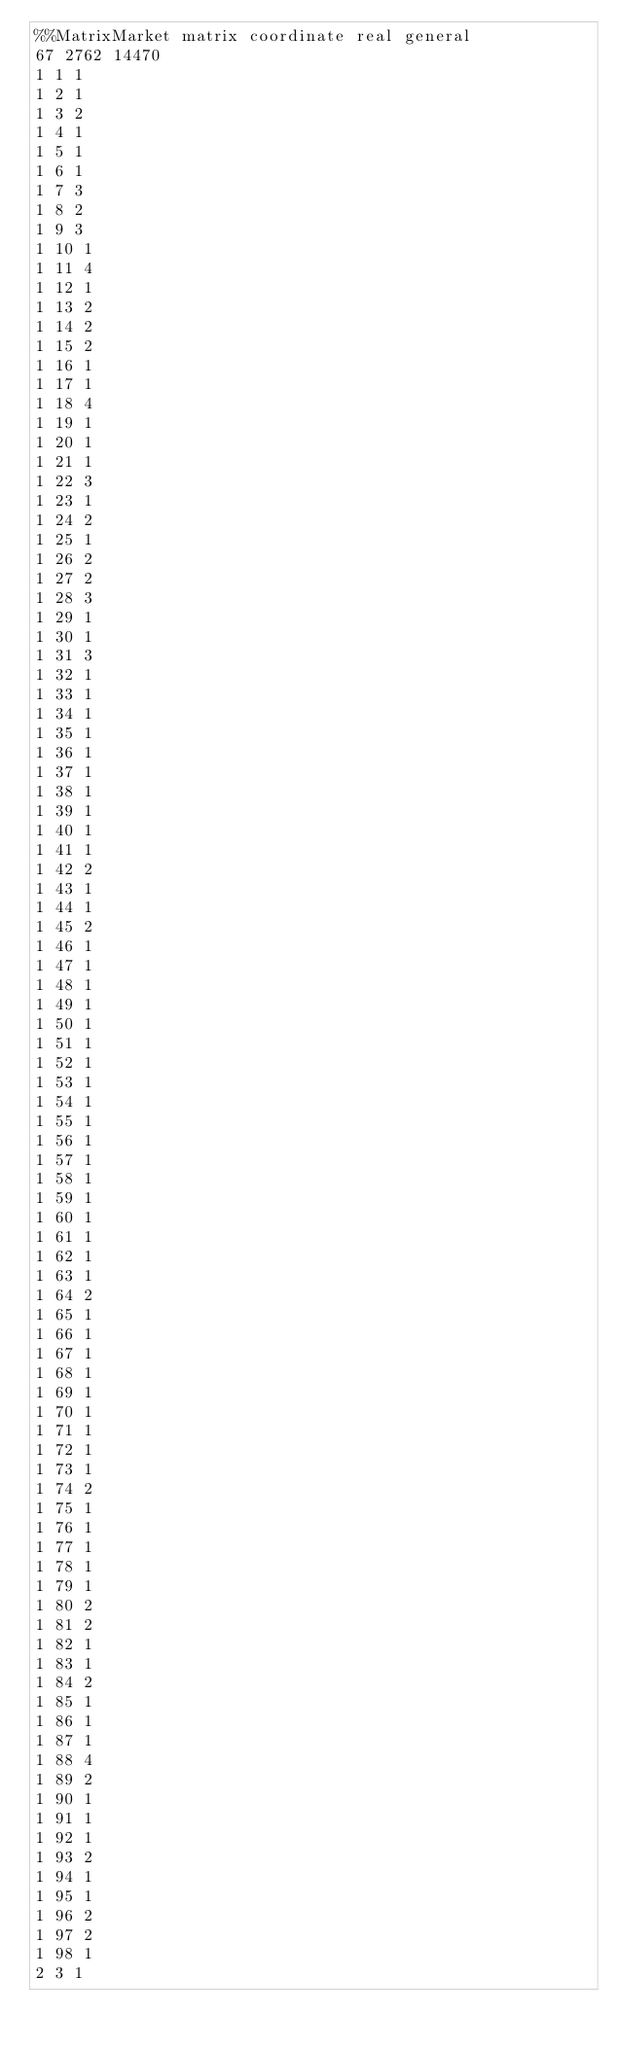Convert code to text. <code><loc_0><loc_0><loc_500><loc_500><_ObjectiveC_>%%MatrixMarket matrix coordinate real general
67 2762 14470                                     
1 1 1
1 2 1
1 3 2
1 4 1
1 5 1
1 6 1
1 7 3
1 8 2
1 9 3
1 10 1
1 11 4
1 12 1
1 13 2
1 14 2
1 15 2
1 16 1
1 17 1
1 18 4
1 19 1
1 20 1
1 21 1
1 22 3
1 23 1
1 24 2
1 25 1
1 26 2
1 27 2
1 28 3
1 29 1
1 30 1
1 31 3
1 32 1
1 33 1
1 34 1
1 35 1
1 36 1
1 37 1
1 38 1
1 39 1
1 40 1
1 41 1
1 42 2
1 43 1
1 44 1
1 45 2
1 46 1
1 47 1
1 48 1
1 49 1
1 50 1
1 51 1
1 52 1
1 53 1
1 54 1
1 55 1
1 56 1
1 57 1
1 58 1
1 59 1
1 60 1
1 61 1
1 62 1
1 63 1
1 64 2
1 65 1
1 66 1
1 67 1
1 68 1
1 69 1
1 70 1
1 71 1
1 72 1
1 73 1
1 74 2
1 75 1
1 76 1
1 77 1
1 78 1
1 79 1
1 80 2
1 81 2
1 82 1
1 83 1
1 84 2
1 85 1
1 86 1
1 87 1
1 88 4
1 89 2
1 90 1
1 91 1
1 92 1
1 93 2
1 94 1
1 95 1
1 96 2
1 97 2
1 98 1
2 3 1</code> 